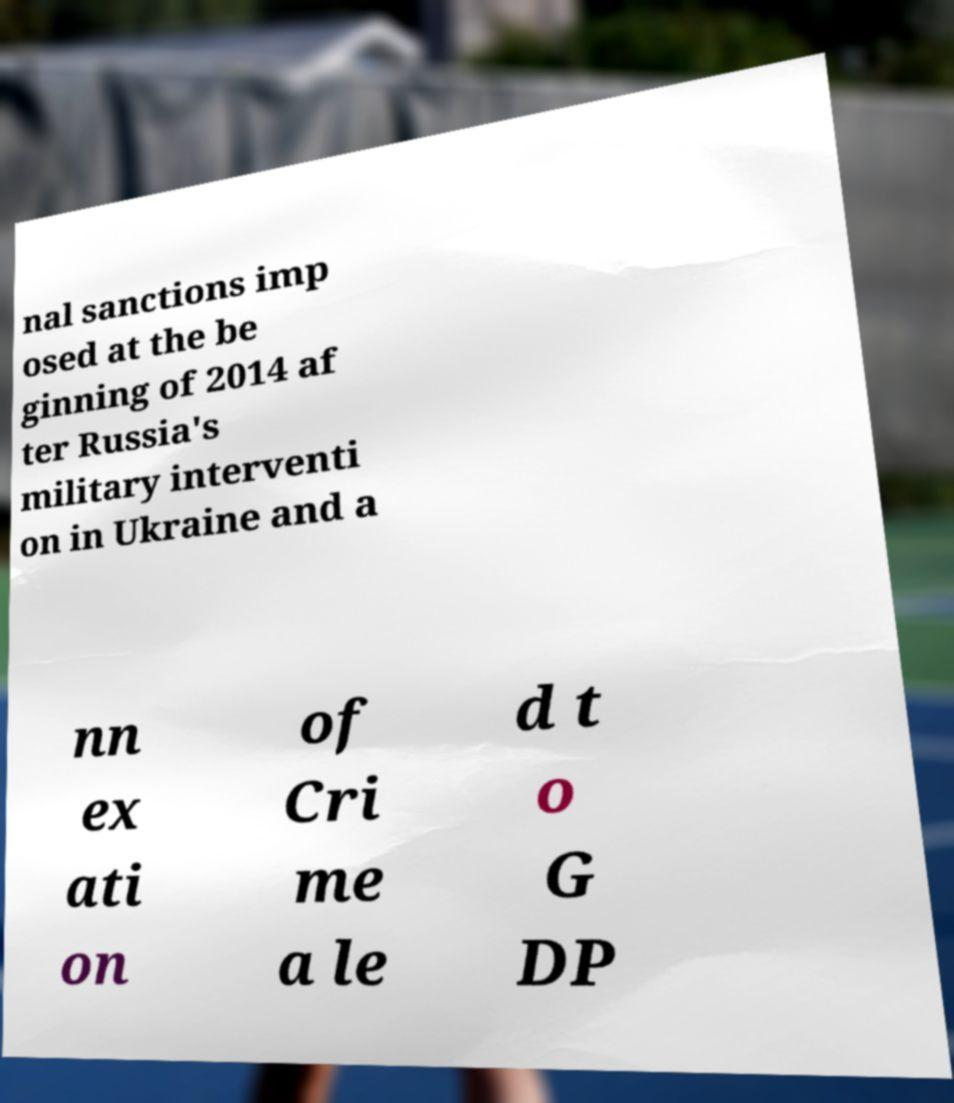Please identify and transcribe the text found in this image. nal sanctions imp osed at the be ginning of 2014 af ter Russia's military interventi on in Ukraine and a nn ex ati on of Cri me a le d t o G DP 